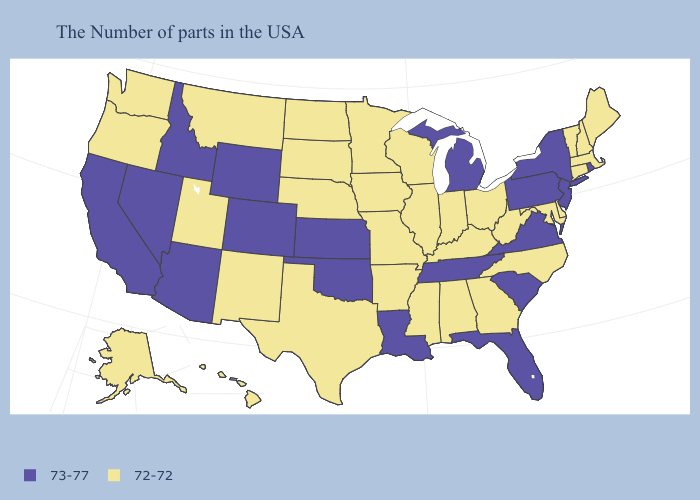What is the lowest value in the Northeast?
Answer briefly. 72-72. Name the states that have a value in the range 73-77?
Write a very short answer. Rhode Island, New York, New Jersey, Pennsylvania, Virginia, South Carolina, Florida, Michigan, Tennessee, Louisiana, Kansas, Oklahoma, Wyoming, Colorado, Arizona, Idaho, Nevada, California. What is the value of Connecticut?
Concise answer only. 72-72. Is the legend a continuous bar?
Be succinct. No. What is the value of Nevada?
Give a very brief answer. 73-77. What is the highest value in the USA?
Keep it brief. 73-77. Is the legend a continuous bar?
Short answer required. No. Name the states that have a value in the range 73-77?
Write a very short answer. Rhode Island, New York, New Jersey, Pennsylvania, Virginia, South Carolina, Florida, Michigan, Tennessee, Louisiana, Kansas, Oklahoma, Wyoming, Colorado, Arizona, Idaho, Nevada, California. Which states have the lowest value in the USA?
Quick response, please. Maine, Massachusetts, New Hampshire, Vermont, Connecticut, Delaware, Maryland, North Carolina, West Virginia, Ohio, Georgia, Kentucky, Indiana, Alabama, Wisconsin, Illinois, Mississippi, Missouri, Arkansas, Minnesota, Iowa, Nebraska, Texas, South Dakota, North Dakota, New Mexico, Utah, Montana, Washington, Oregon, Alaska, Hawaii. Does the first symbol in the legend represent the smallest category?
Quick response, please. No. Name the states that have a value in the range 73-77?
Keep it brief. Rhode Island, New York, New Jersey, Pennsylvania, Virginia, South Carolina, Florida, Michigan, Tennessee, Louisiana, Kansas, Oklahoma, Wyoming, Colorado, Arizona, Idaho, Nevada, California. Name the states that have a value in the range 73-77?
Be succinct. Rhode Island, New York, New Jersey, Pennsylvania, Virginia, South Carolina, Florida, Michigan, Tennessee, Louisiana, Kansas, Oklahoma, Wyoming, Colorado, Arizona, Idaho, Nevada, California. Name the states that have a value in the range 72-72?
Keep it brief. Maine, Massachusetts, New Hampshire, Vermont, Connecticut, Delaware, Maryland, North Carolina, West Virginia, Ohio, Georgia, Kentucky, Indiana, Alabama, Wisconsin, Illinois, Mississippi, Missouri, Arkansas, Minnesota, Iowa, Nebraska, Texas, South Dakota, North Dakota, New Mexico, Utah, Montana, Washington, Oregon, Alaska, Hawaii. Name the states that have a value in the range 72-72?
Give a very brief answer. Maine, Massachusetts, New Hampshire, Vermont, Connecticut, Delaware, Maryland, North Carolina, West Virginia, Ohio, Georgia, Kentucky, Indiana, Alabama, Wisconsin, Illinois, Mississippi, Missouri, Arkansas, Minnesota, Iowa, Nebraska, Texas, South Dakota, North Dakota, New Mexico, Utah, Montana, Washington, Oregon, Alaska, Hawaii. What is the value of Colorado?
Write a very short answer. 73-77. 